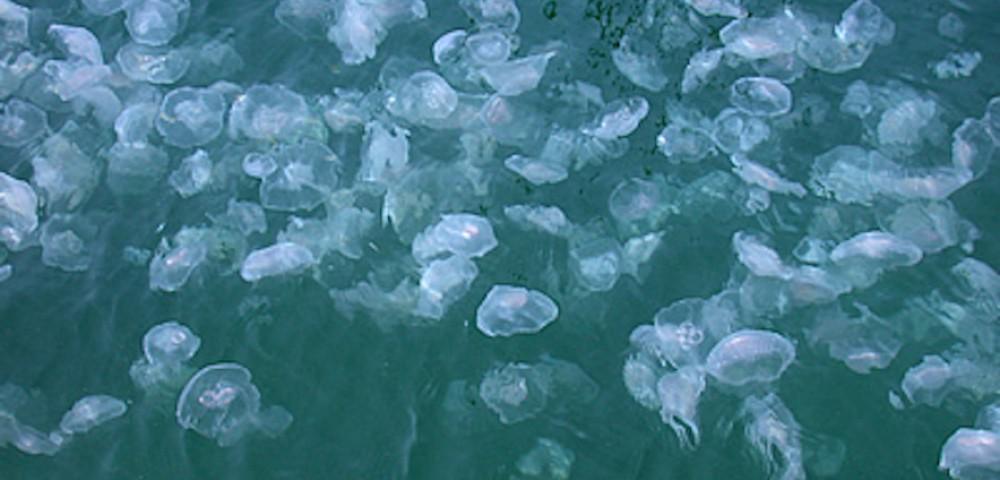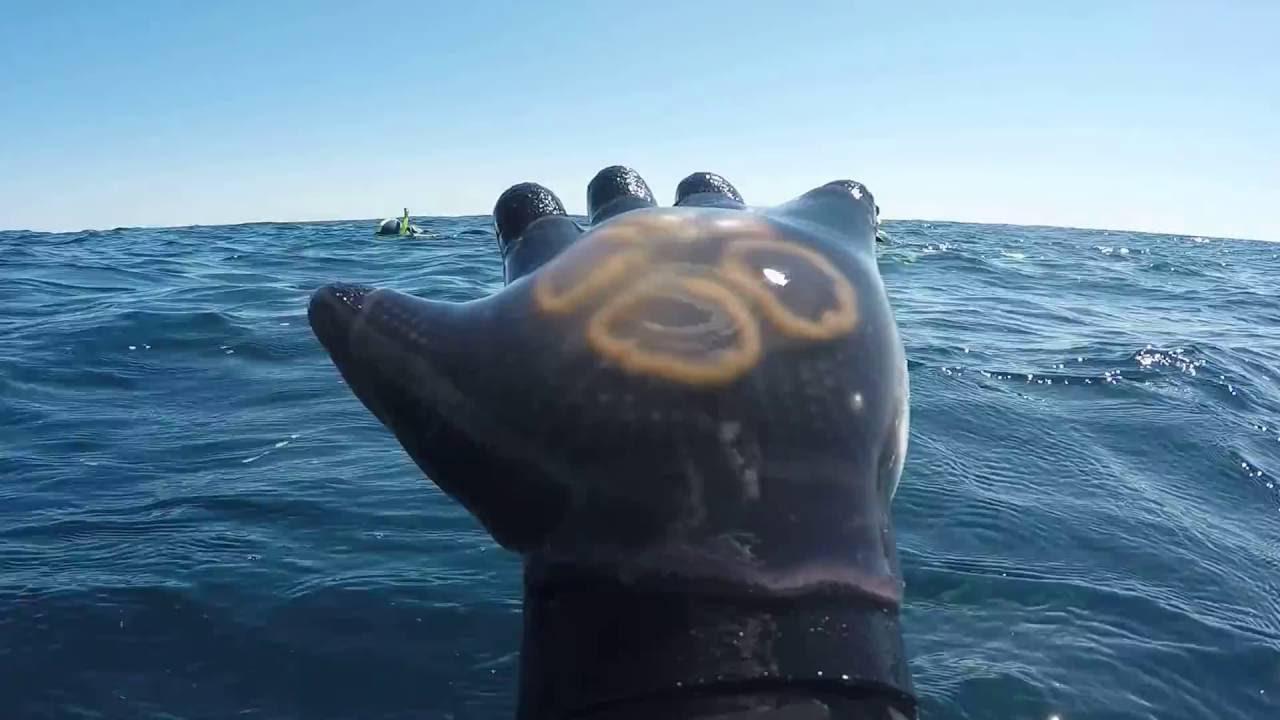The first image is the image on the left, the second image is the image on the right. For the images shown, is this caption "One photo shows a large group of yellow-tinted jellyfish." true? Answer yes or no. No. 